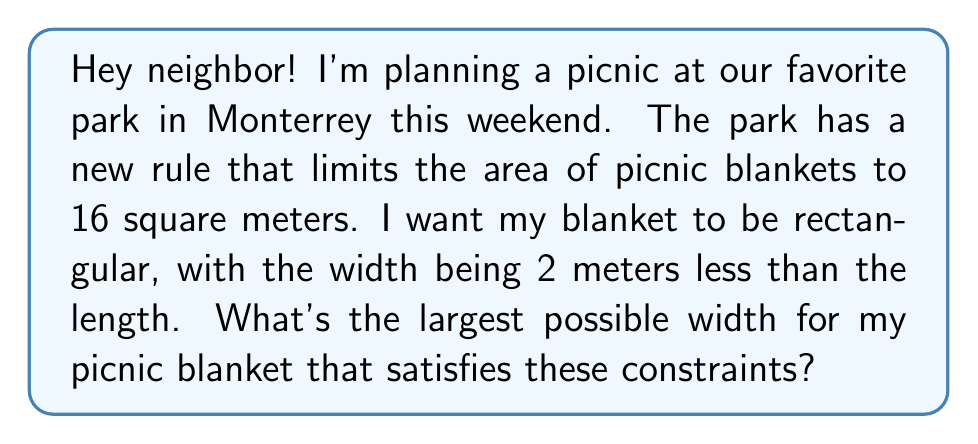Teach me how to tackle this problem. Let's approach this step-by-step:

1) Let's define our variables:
   $w$ = width of the blanket
   $l$ = length of the blanket

2) We're told that the width is 2 meters less than the length:
   $w = l - 2$

3) The area of the blanket is limited to 16 square meters:
   $A = w \cdot l \leq 16$

4) Substituting the width equation into the area inequality:
   $(l - 2) \cdot l \leq 16$

5) Expanding this:
   $l^2 - 2l \leq 16$

6) Rearranging to standard quadratic form:
   $l^2 - 2l - 16 \leq 0$

7) This is a quadratic inequality. To solve it, we first find the roots of the equation $l^2 - 2l - 16 = 0$:
   
   Using the quadratic formula: $l = \frac{-b \pm \sqrt{b^2 - 4ac}}{2a}$
   
   $l = \frac{2 \pm \sqrt{4 + 64}}{2} = \frac{2 \pm \sqrt{68}}{2}$

8) The roots are:
   $l_1 = \frac{2 + \sqrt{68}}{2} \approx 5.12$ and $l_2 = \frac{2 - \sqrt{68}}{2} \approx -3.12$

9) Since length can't be negative, we only consider the positive root. The inequality is satisfied when $0 \leq l \leq 5.12$

10) Remember, we want the width. Using $w = l - 2$, the maximum width is:
    $w_{max} = 5.12 - 2 = 3.12$ meters
Answer: The largest possible width for the picnic blanket is approximately 3.12 meters. 